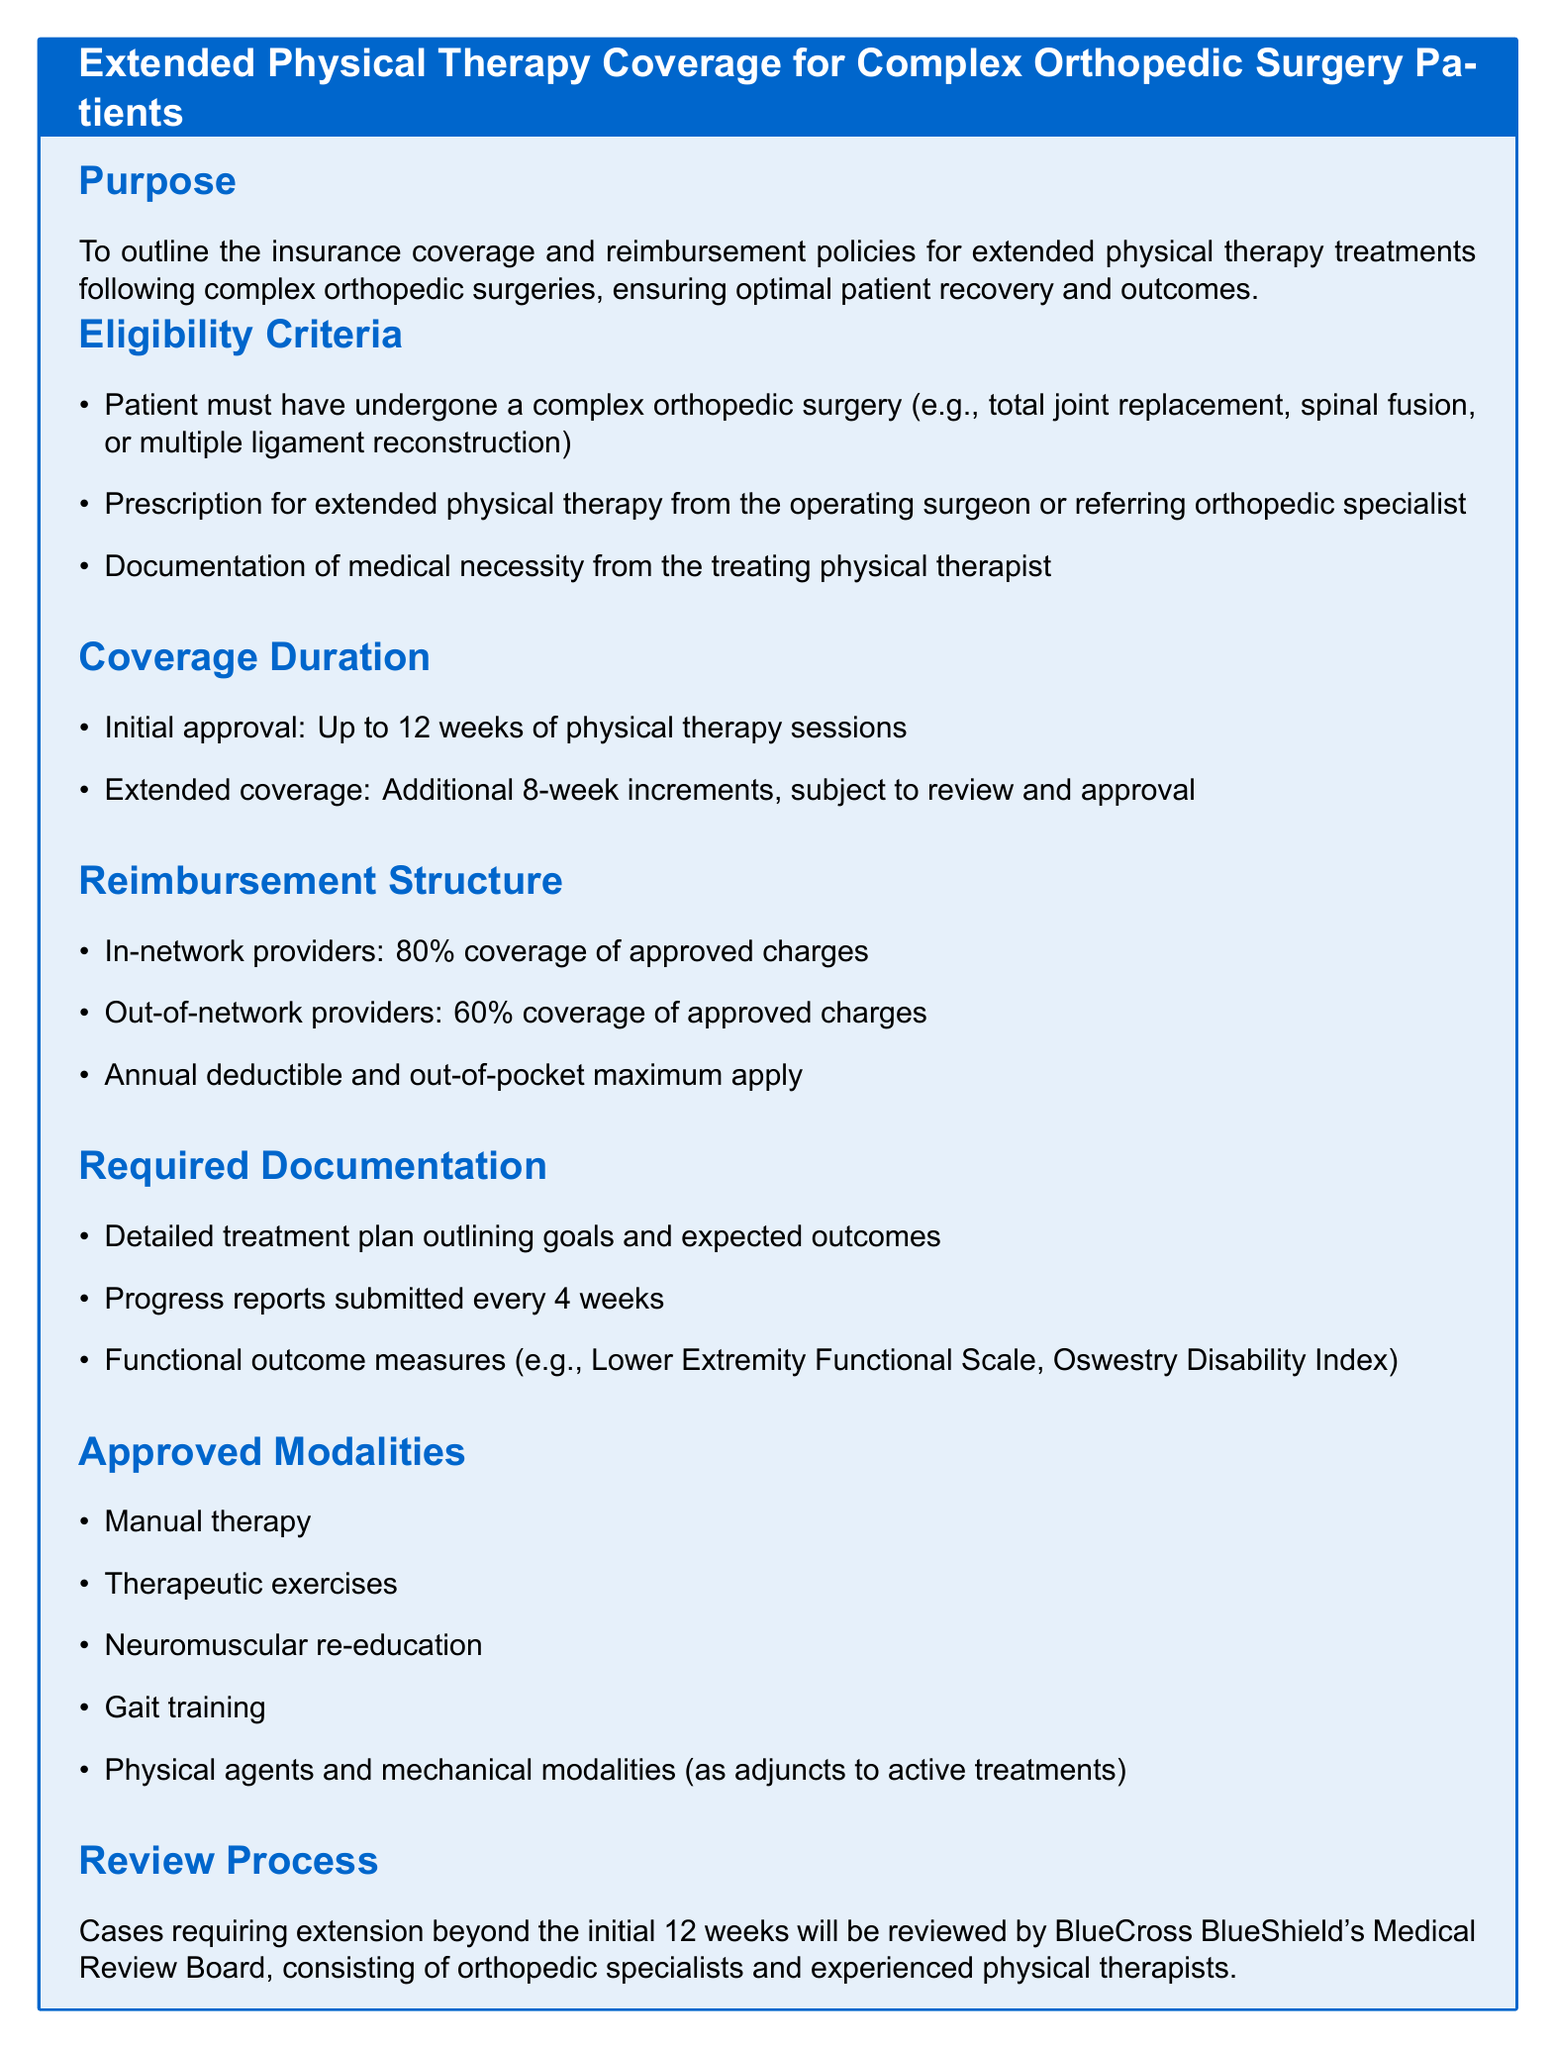What is the purpose of the document? The document outlines insurance coverage and reimbursement policies for extended physical therapy treatments following complex orthopedic surgeries, ensuring optimal patient recovery and outcomes.
Answer: To outline insurance coverage and reimbursement policies for extended physical therapy treatments following complex orthopedic surgeries What is the initial approval duration for physical therapy sessions? The document specifies that the initial approval is for up to 12 weeks of physical therapy sessions.
Answer: Up to 12 weeks What percentage of coverage do in-network providers receive? According to the document, in-network providers receive 80% coverage of approved charges.
Answer: 80% What documentation is required every 4 weeks? The document states that progress reports must be submitted every 4 weeks as part of the required documentation.
Answer: Progress reports Who reviews cases requiring extension beyond the initial 12 weeks? The document mentions that cases requiring an extension are reviewed by BlueCross BlueShield's Medical Review Board, which consists of specialists and experienced therapists.
Answer: BlueCross BlueShield's Medical Review Board What is one approved modality for physical therapy? The document lists manual therapy as one of the approved modalities for physical therapy.
Answer: Manual therapy How many total weeks can be extended if approved? The document indicates that additional coverage can be approved in increments of 8 weeks, but does not specify the total number possible.
Answer: Additional 8-week increments What is the first eligibility criterion for the coverage? The first eligibility criterion in the document is that the patient must have undergone a complex orthopedic surgery.
Answer: Complex orthopedic surgery 